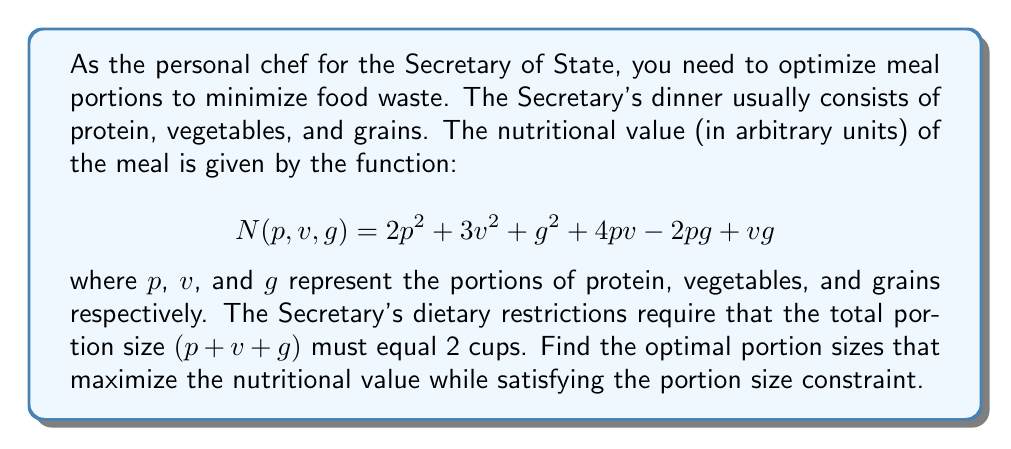Can you answer this question? To solve this optimization problem with constraints, we'll use the method of Lagrange multipliers.

1) First, we define the Lagrangian function:
   $$L(p,v,g,\lambda) = N(p,v,g) - \lambda(p + v + g - 2)$$
   $$L(p,v,g,\lambda) = 2p^2 + 3v^2 + g^2 + 4pv - 2pg + vg - \lambda(p + v + g - 2)$$

2) Now, we take partial derivatives and set them equal to zero:

   $$\frac{\partial L}{\partial p} = 4p + 4v - 2g - \lambda = 0$$
   $$\frac{\partial L}{\partial v} = 6v + 4p + g - \lambda = 0$$
   $$\frac{\partial L}{\partial g} = 2g - 2p + v - \lambda = 0$$
   $$\frac{\partial L}{\partial \lambda} = -(p + v + g - 2) = 0$$

3) From the last equation, we get our constraint:
   $$p + v + g = 2$$

4) Subtracting the third equation from the first:
   $$4p + 4v - 2g - (2g - 2p + v) = 0$$
   $$6p + 3v - 4g = 0 \quad (1)$$

5) Subtracting the third equation from the second:
   $$6v + 4p + g - (2g - 2p + v) = 0$$
   $$6p + 5v - g = 0 \quad (2)$$

6) From (1) and (2), we can derive:
   $$6p + 3v - 4g = 6p + 5v - g$$
   $$-2v = 3g$$
   $$v = -\frac{3}{2}g$$

7) Substituting this into (2):
   $$6p - \frac{15}{2}g - g = 0$$
   $$6p = \frac{17}{2}g$$
   $$p = \frac{17}{12}g$$

8) Using the constraint equation:
   $$\frac{17}{12}g - \frac{3}{2}g + g = 2$$
   $$\frac{17}{12}g - \frac{6}{4}g + \frac{12}{12}g = 2$$
   $$\frac{23}{12}g = 2$$
   $$g = \frac{24}{23}$$

9) Substituting back:
   $$p = \frac{17}{12} \cdot \frac{24}{23} = \frac{17}{23}$$
   $$v = -\frac{3}{2} \cdot \frac{24}{23} = -\frac{36}{23}$$

However, since portions cannot be negative, we need to reconsider our solution. The negative value for vegetables suggests that the optimal solution lies on the boundary where $v = 0$.

10) If $v = 0$, then from the constraint:
    $$p + g = 2$$

11) Substituting this into the original function:
    $$N(p,2-p,0) = 2p^2 + (2-p)^2 - 2p(2-p)$$
    $$= 2p^2 + 4 - 4p + p^2 - 4p + 2p^2$$
    $$= 5p^2 - 8p + 4$$

12) To find the maximum, we differentiate and set to zero:
    $$\frac{dN}{dp} = 10p - 8 = 0$$
    $$p = \frac{4}{5} = 0.8$$

13) Therefore:
    $$g = 2 - p = 2 - 0.8 = 1.2$$
Answer: The optimal portion sizes are:
Protein (p): $\frac{4}{5}$ cups (or 0.8 cups)
Vegetables (v): 0 cups
Grains (g): $\frac{6}{5}$ cups (or 1.2 cups) 